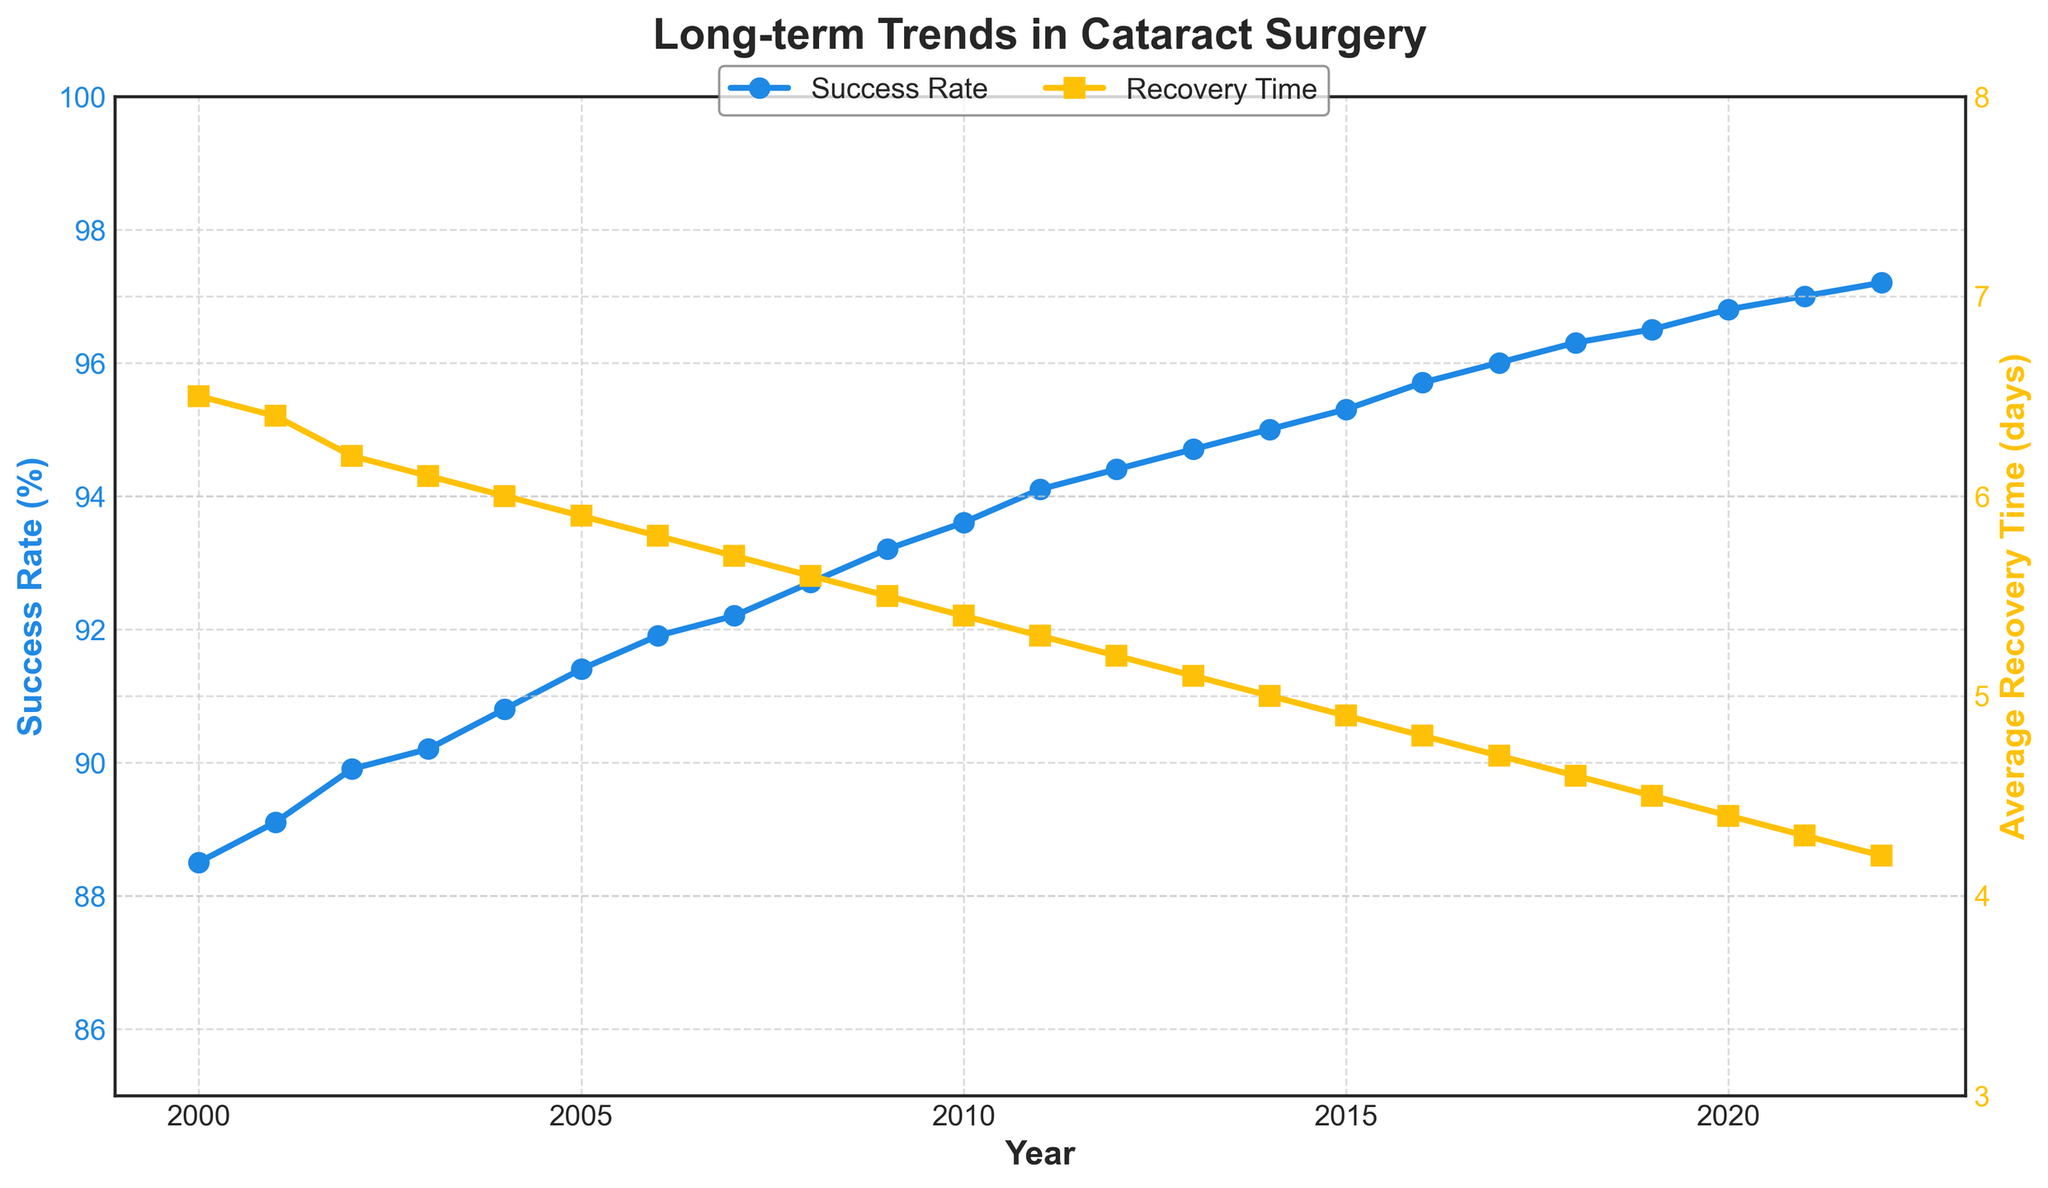What is the title of the figure? The title of the figure can be found at the top of the plot in bold, larger font. In this case, it reads "Long-term Trends in Cataract Surgery."
Answer: Long-term Trends in Cataract Surgery How many years of data are presented in the plot? To determine the number of years presented, we look at the X-axis, which shows the range from 2000 to 2022. Counting the years from the start to the end gives 23 years.
Answer: 23 What color represents the Success Rate in the plot? The color representing the Success Rate can be identified by observing the color of the line and markers associated with it. Here, the line and markers are in blue.
Answer: Blue What trend do you observe in the Average Recovery Time over the years? Observing the plot, we note that the Average Recovery Time decreases steadily from 6.5 days in 2000 to 4.2 days in 2022. This indicates a downward trend.
Answer: Decreasing What is the success rate in 2010? To find the success rate for 2010, we locate the X-axis at the year 2010 and see the corresponding point on the Success Rate Y-axis. The value is marked as approximately 93.6%.
Answer: 93.6% How much did the success rate improve from 2000 to 2022? To find the improvement, subtract the success rate in 2000 (88.5%) from that in 2022 (97.2%). The difference is 97.2% - 88.5% = 8.7%.
Answer: 8.7% In which year did the Average Recovery Time first drop below 5 days? To find this, we track the trend of the Average Recovery Time line on the plot. The first below-5-day marker is at 2015, with a recovery time of 4.9 days.
Answer: 2015 Compare the Success Rate and Average Recovery Time in 2008. To compare both values for 2008, refer to their respective axis points for that year. The Success Rate is 92.7%, and the Average Recovery Time is 5.6 days.
Answer: 92.7%, 5.6 days What is the average Success Rate over the entire period? To calculate the average, sum all Success Rate values from the data and divide by the number of years (23). The calculation (((88.5+89.1+89.9+...+97.2))/23) results in an average of approximately 93.3%.
Answer: 93.3% Which year shows the greatest improvement in Success Rate when compared to the previous year? Comparing each successive year's Success Rate, the greatest year-over-year improvement occurs between 2021 (97.0%) and 2022 (97.2%), showing an increase of 0.2%.
Answer: 2022 